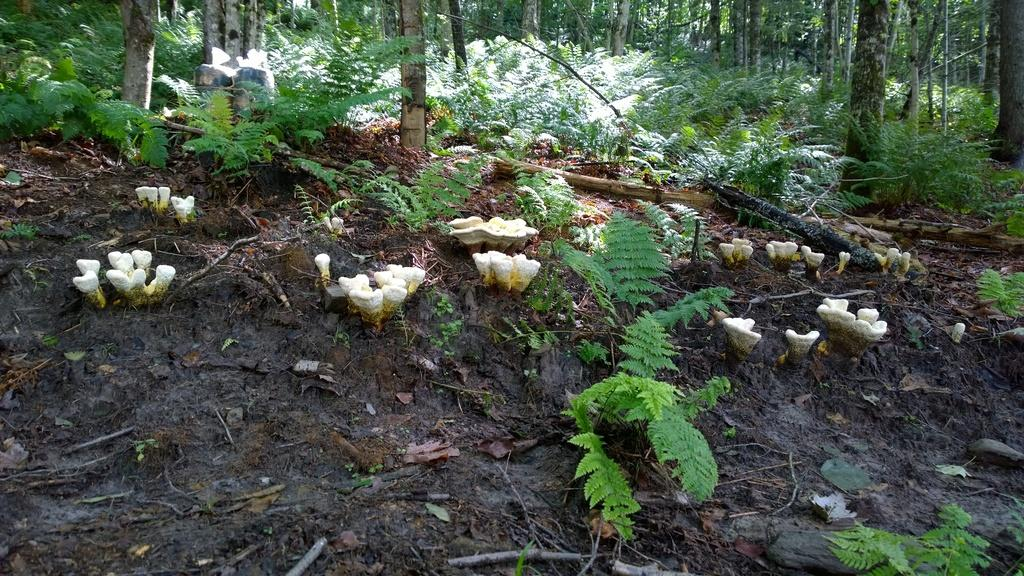What type of natural environment is depicted in the image? There is a forest in the image. What can be found on the land in the middle of the forest? Mushrooms are visible on the land in the middle of the forest. What type of vegetation is present in the forest? There are trees in the forest. What type of behavior can be observed in the map in the image? There is no map present in the image, so it is not possible to observe any behavior related to a map. 